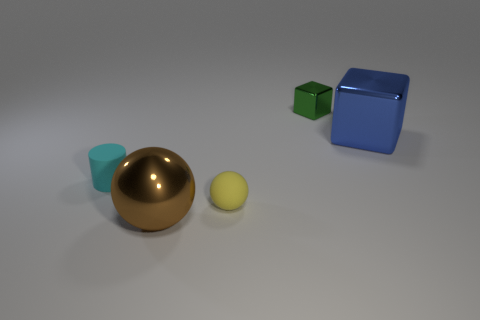Add 3 small rubber blocks. How many objects exist? 8 Subtract 1 cubes. How many cubes are left? 1 Subtract all yellow balls. How many balls are left? 1 Subtract all balls. How many objects are left? 3 Subtract all purple spheres. Subtract all cyan cylinders. How many spheres are left? 2 Subtract all green cubes. How many purple balls are left? 0 Subtract all large blue cubes. Subtract all tiny gray metal objects. How many objects are left? 4 Add 2 brown shiny things. How many brown shiny things are left? 3 Add 3 tiny green things. How many tiny green things exist? 4 Subtract 1 brown balls. How many objects are left? 4 